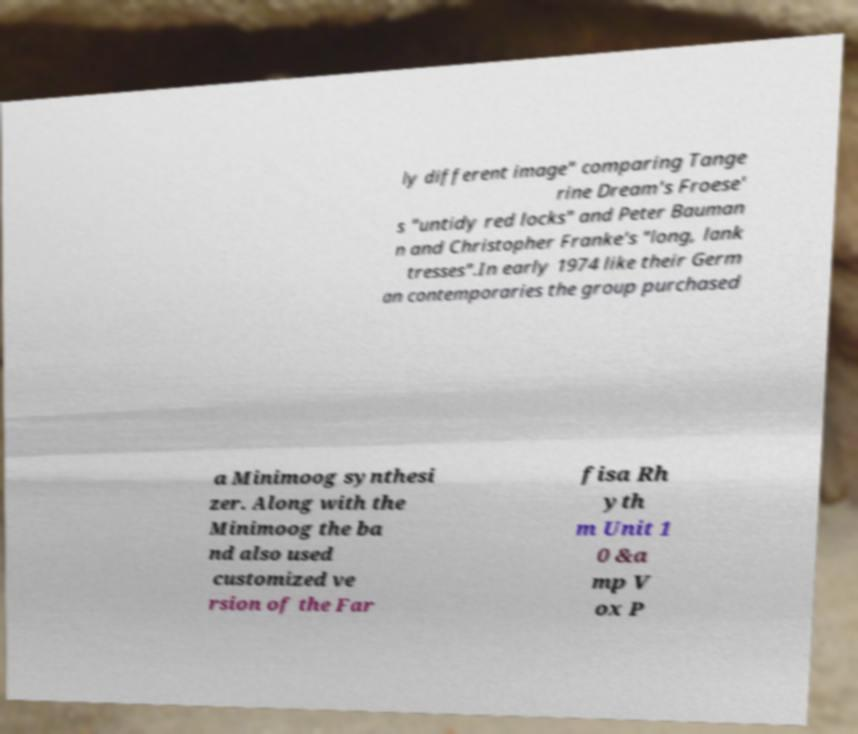Could you extract and type out the text from this image? ly different image" comparing Tange rine Dream's Froese' s "untidy red locks" and Peter Bauman n and Christopher Franke's "long, lank tresses".In early 1974 like their Germ an contemporaries the group purchased a Minimoog synthesi zer. Along with the Minimoog the ba nd also used customized ve rsion of the Far fisa Rh yth m Unit 1 0 &a mp V ox P 